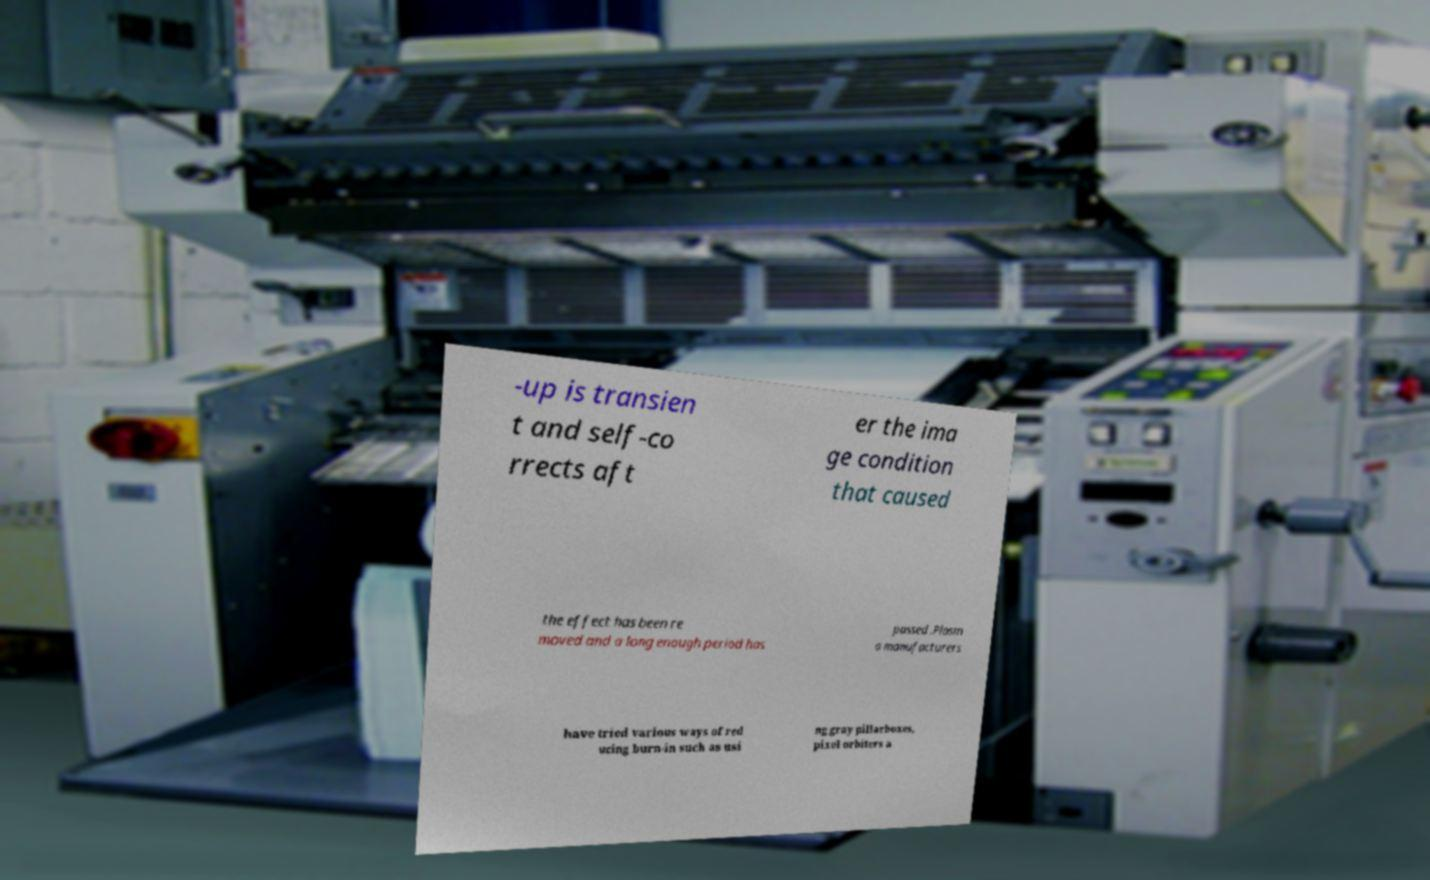Could you assist in decoding the text presented in this image and type it out clearly? -up is transien t and self-co rrects aft er the ima ge condition that caused the effect has been re moved and a long enough period has passed .Plasm a manufacturers have tried various ways of red ucing burn-in such as usi ng gray pillarboxes, pixel orbiters a 